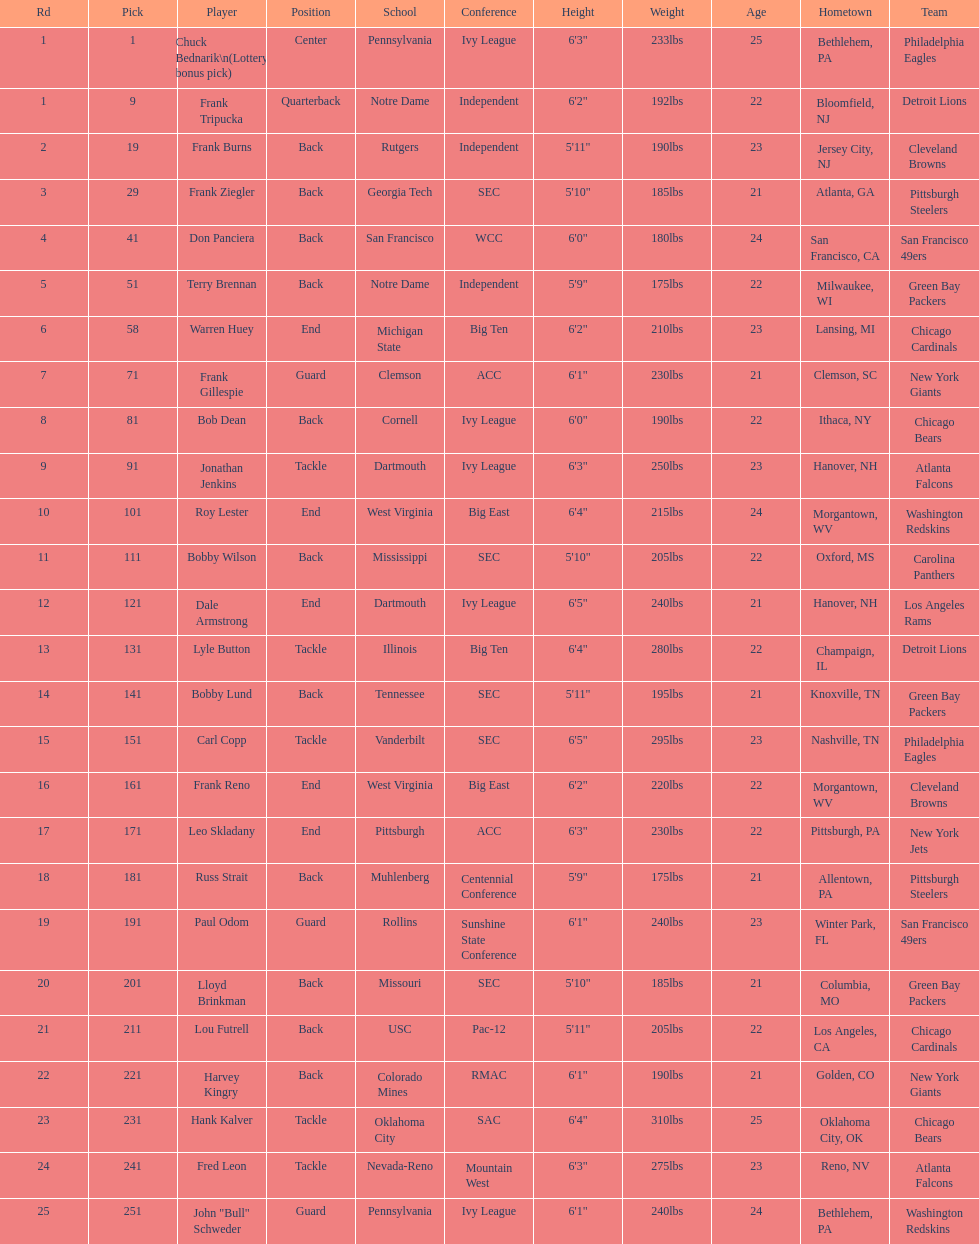Parse the table in full. {'header': ['Rd', 'Pick', 'Player', 'Position', 'School', 'Conference', 'Height', 'Weight', 'Age', 'Hometown', 'Team'], 'rows': [['1', '1', 'Chuck Bednarik\\n(Lottery bonus pick)', 'Center', 'Pennsylvania', 'Ivy League', '6\'3"', '233lbs', '25', 'Bethlehem, PA', 'Philadelphia Eagles'], ['1', '9', 'Frank Tripucka', 'Quarterback', 'Notre Dame', 'Independent', '6\'2"', '192lbs', '22', 'Bloomfield, NJ', 'Detroit Lions'], ['2', '19', 'Frank Burns', 'Back', 'Rutgers', 'Independent', '5\'11"', '190lbs', '23', 'Jersey City, NJ', 'Cleveland  Browns'], ['3', '29', 'Frank Ziegler', 'Back', 'Georgia Tech', 'SEC', '5\'10"', '185lbs', '21', 'Atlanta, GA', 'Pittsburgh Steelers'], ['4', '41', 'Don Panciera', 'Back', 'San Francisco', 'WCC', '6\'0"', '180lbs', '24', 'San Francisco, CA', 'San Francisco 49ers'], ['5', '51', 'Terry Brennan', 'Back', 'Notre Dame', 'Independent', '5\'9"', '175lbs', '22', 'Milwaukee, WI', 'Green Bay Packers'], ['6', '58', 'Warren Huey', 'End', 'Michigan State', 'Big Ten', '6\'2"', '210lbs', '23', 'Lansing, MI', 'Chicago Cardinals'], ['7', '71', 'Frank Gillespie', 'Guard', 'Clemson', 'ACC', '6\'1"', '230lbs', '21', 'Clemson, SC', 'New York Giants'], ['8', '81', 'Bob Dean', 'Back', 'Cornell', 'Ivy League', '6\'0"', '190lbs', '22', 'Ithaca, NY', 'Chicago Bears'], ['9', '91', 'Jonathan Jenkins', 'Tackle', 'Dartmouth', 'Ivy League', '6\'3"', '250lbs', '23', 'Hanover, NH', 'Atlanta Falcons'], ['10', '101', 'Roy Lester', 'End', 'West Virginia', 'Big East', '6\'4"', '215lbs', '24', 'Morgantown, WV', 'Washington Redskins'], ['11', '111', 'Bobby Wilson', 'Back', 'Mississippi', 'SEC', '5\'10"', '205lbs', '22', 'Oxford, MS', 'Carolina Panthers'], ['12', '121', 'Dale Armstrong', 'End', 'Dartmouth', 'Ivy League', '6\'5"', '240lbs', '21', 'Hanover, NH', 'Los Angeles Rams'], ['13', '131', 'Lyle Button', 'Tackle', 'Illinois', 'Big Ten', '6\'4"', '280lbs', '22', 'Champaign, IL', 'Detroit Lions'], ['14', '141', 'Bobby Lund', 'Back', 'Tennessee', 'SEC', '5\'11"', '195lbs', '21', 'Knoxville, TN', 'Green Bay Packers'], ['15', '151', 'Carl Copp', 'Tackle', 'Vanderbilt', 'SEC', '6\'5"', '295lbs', '23', 'Nashville, TN', 'Philadelphia Eagles'], ['16', '161', 'Frank Reno', 'End', 'West Virginia', 'Big East', '6\'2"', '220lbs', '22', 'Morgantown, WV', 'Cleveland Browns'], ['17', '171', 'Leo Skladany', 'End', 'Pittsburgh', 'ACC', '6\'3"', '230lbs', '22', 'Pittsburgh, PA', 'New York Jets'], ['18', '181', 'Russ Strait', 'Back', 'Muhlenberg', 'Centennial Conference', '5\'9"', '175lbs', '21', 'Allentown, PA', 'Pittsburgh Steelers'], ['19', '191', 'Paul Odom', 'Guard', 'Rollins', 'Sunshine State Conference', '6\'1"', '240lbs', '23', 'Winter Park, FL', 'San Francisco 49ers'], ['20', '201', 'Lloyd Brinkman', 'Back', 'Missouri', 'SEC', '5\'10"', '185lbs', '21', 'Columbia, MO', 'Green Bay Packers'], ['21', '211', 'Lou Futrell', 'Back', 'USC', 'Pac-12', '5\'11"', '205lbs', '22', 'Los Angeles, CA', 'Chicago Cardinals'], ['22', '221', 'Harvey Kingry', 'Back', 'Colorado Mines', 'RMAC', '6\'1"', '190lbs', '21', 'Golden, CO', 'New York Giants'], ['23', '231', 'Hank Kalver', 'Tackle', 'Oklahoma City', 'SAC', '6\'4"', '310lbs', '25', 'Oklahoma City, OK', 'Chicago Bears'], ['24', '241', 'Fred Leon', 'Tackle', 'Nevada-Reno', 'Mountain West', '6\'3"', '275lbs', '23', 'Reno, NV', 'Atlanta Falcons'], ['25', '251', 'John "Bull" Schweder', 'Guard', 'Pennsylvania', 'Ivy League', '6\'1"', '240lbs', '24', 'Bethlehem, PA', 'Washington Redskins']]} How many draft choices were there in between the selections of frank tripucka and dale armstrong? 10. 